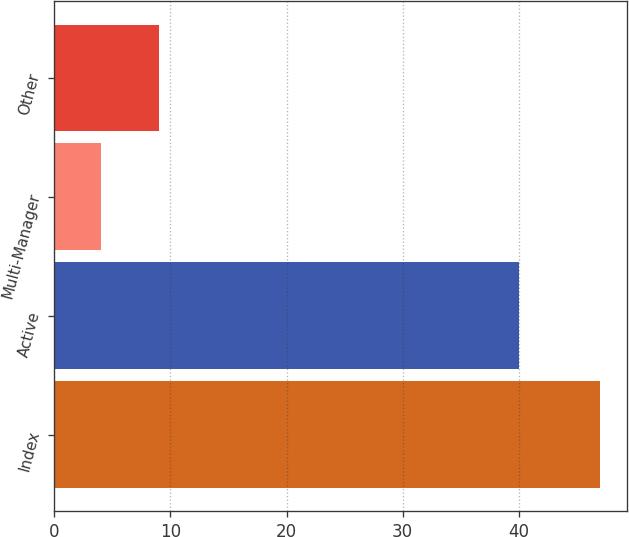Convert chart. <chart><loc_0><loc_0><loc_500><loc_500><bar_chart><fcel>Index<fcel>Active<fcel>Multi-Manager<fcel>Other<nl><fcel>47<fcel>40<fcel>4<fcel>9<nl></chart> 